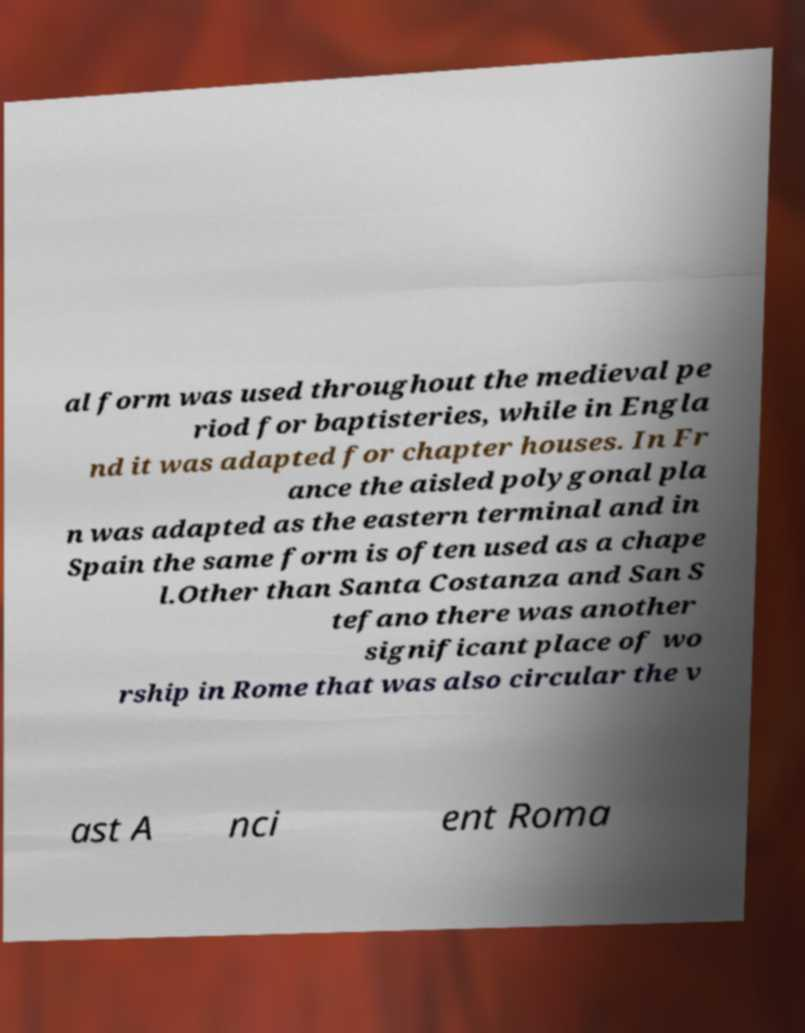What messages or text are displayed in this image? I need them in a readable, typed format. al form was used throughout the medieval pe riod for baptisteries, while in Engla nd it was adapted for chapter houses. In Fr ance the aisled polygonal pla n was adapted as the eastern terminal and in Spain the same form is often used as a chape l.Other than Santa Costanza and San S tefano there was another significant place of wo rship in Rome that was also circular the v ast A nci ent Roma 